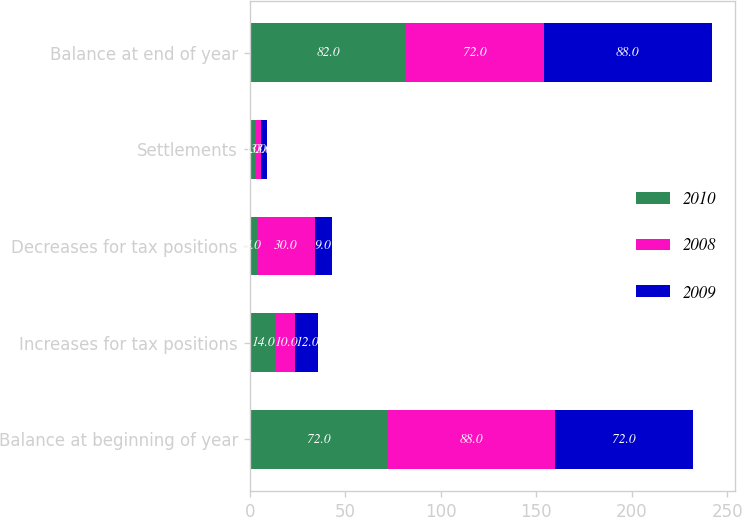Convert chart. <chart><loc_0><loc_0><loc_500><loc_500><stacked_bar_chart><ecel><fcel>Balance at beginning of year<fcel>Increases for tax positions<fcel>Decreases for tax positions<fcel>Settlements<fcel>Balance at end of year<nl><fcel>2010<fcel>72<fcel>14<fcel>4<fcel>3<fcel>82<nl><fcel>2008<fcel>88<fcel>10<fcel>30<fcel>3<fcel>72<nl><fcel>2009<fcel>72<fcel>12<fcel>9<fcel>3<fcel>88<nl></chart> 